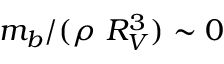<formula> <loc_0><loc_0><loc_500><loc_500>m _ { b } / ( \rho \ R _ { V } ^ { 3 } ) \sim 0</formula> 